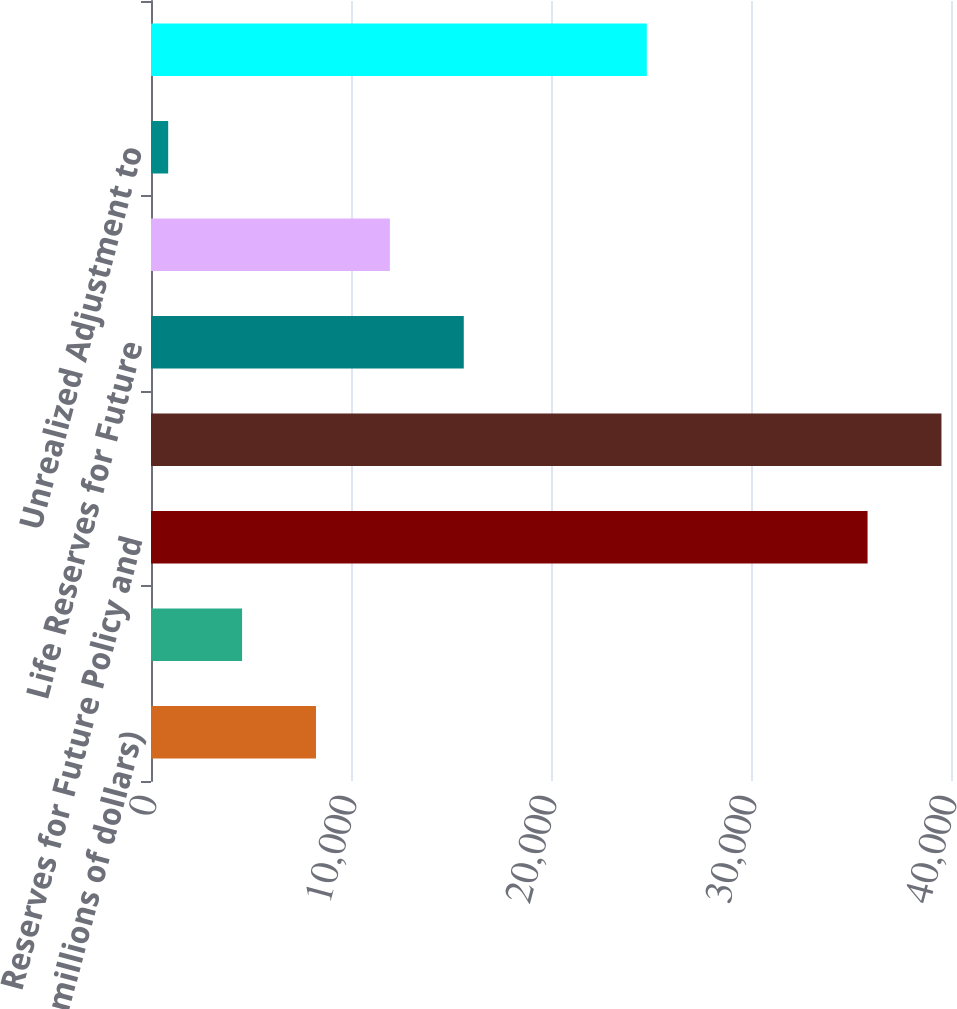Convert chart. <chart><loc_0><loc_0><loc_500><loc_500><bar_chart><fcel>(in millions of dollars)<fcel>Policy and Contract Benefits<fcel>Reserves for Future Policy and<fcel>Total<fcel>Life Reserves for Future<fcel>Accident and Health Active<fcel>Unrealized Adjustment to<fcel>Liability for Unpaid Claims<nl><fcel>8248.98<fcel>4554.14<fcel>35828<fcel>39522.8<fcel>15638.7<fcel>11943.8<fcel>859.3<fcel>24790<nl></chart> 